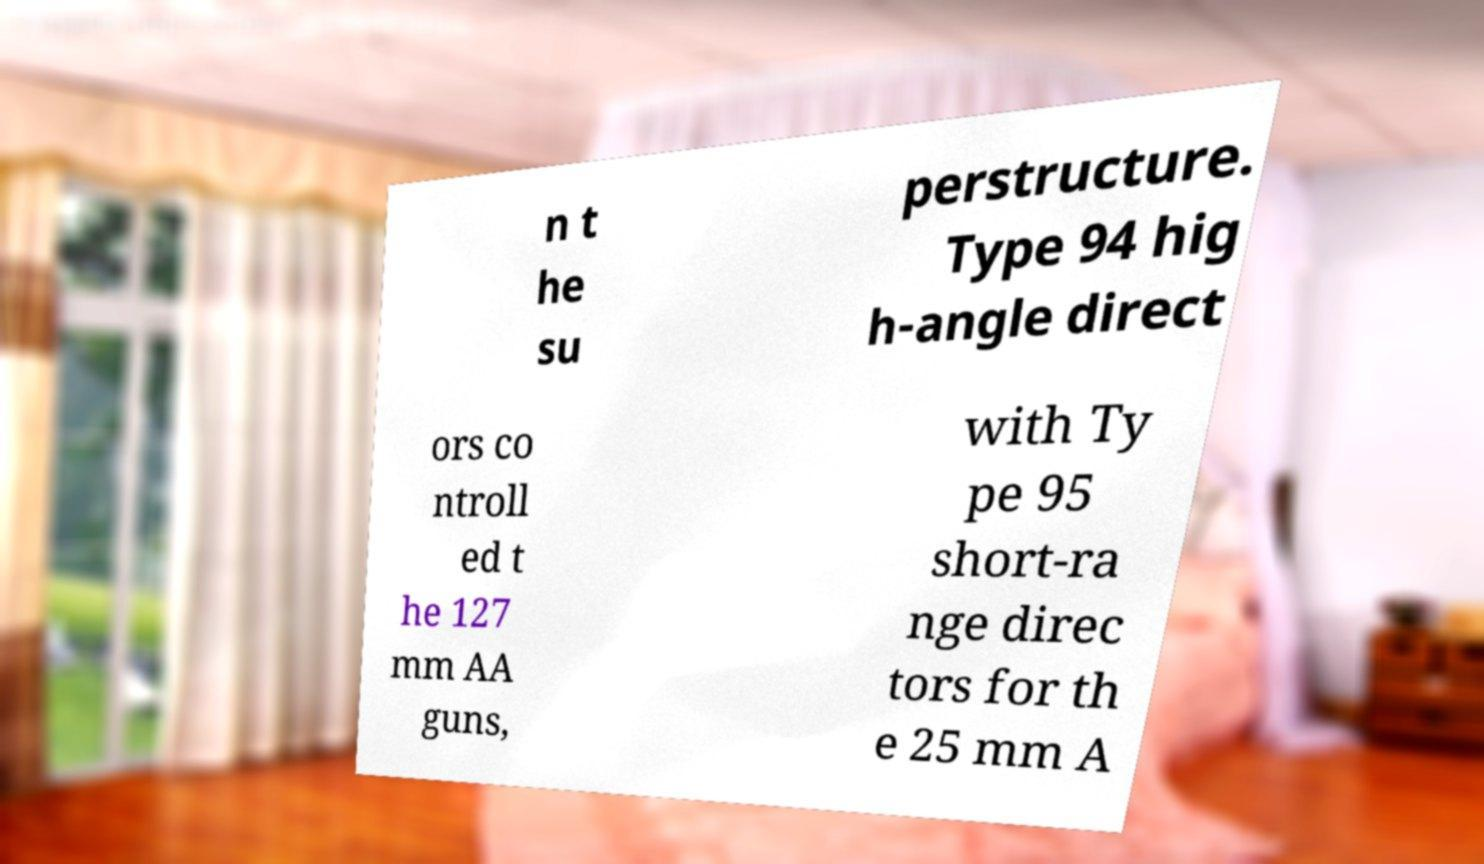Please read and relay the text visible in this image. What does it say? n t he su perstructure. Type 94 hig h-angle direct ors co ntroll ed t he 127 mm AA guns, with Ty pe 95 short-ra nge direc tors for th e 25 mm A 